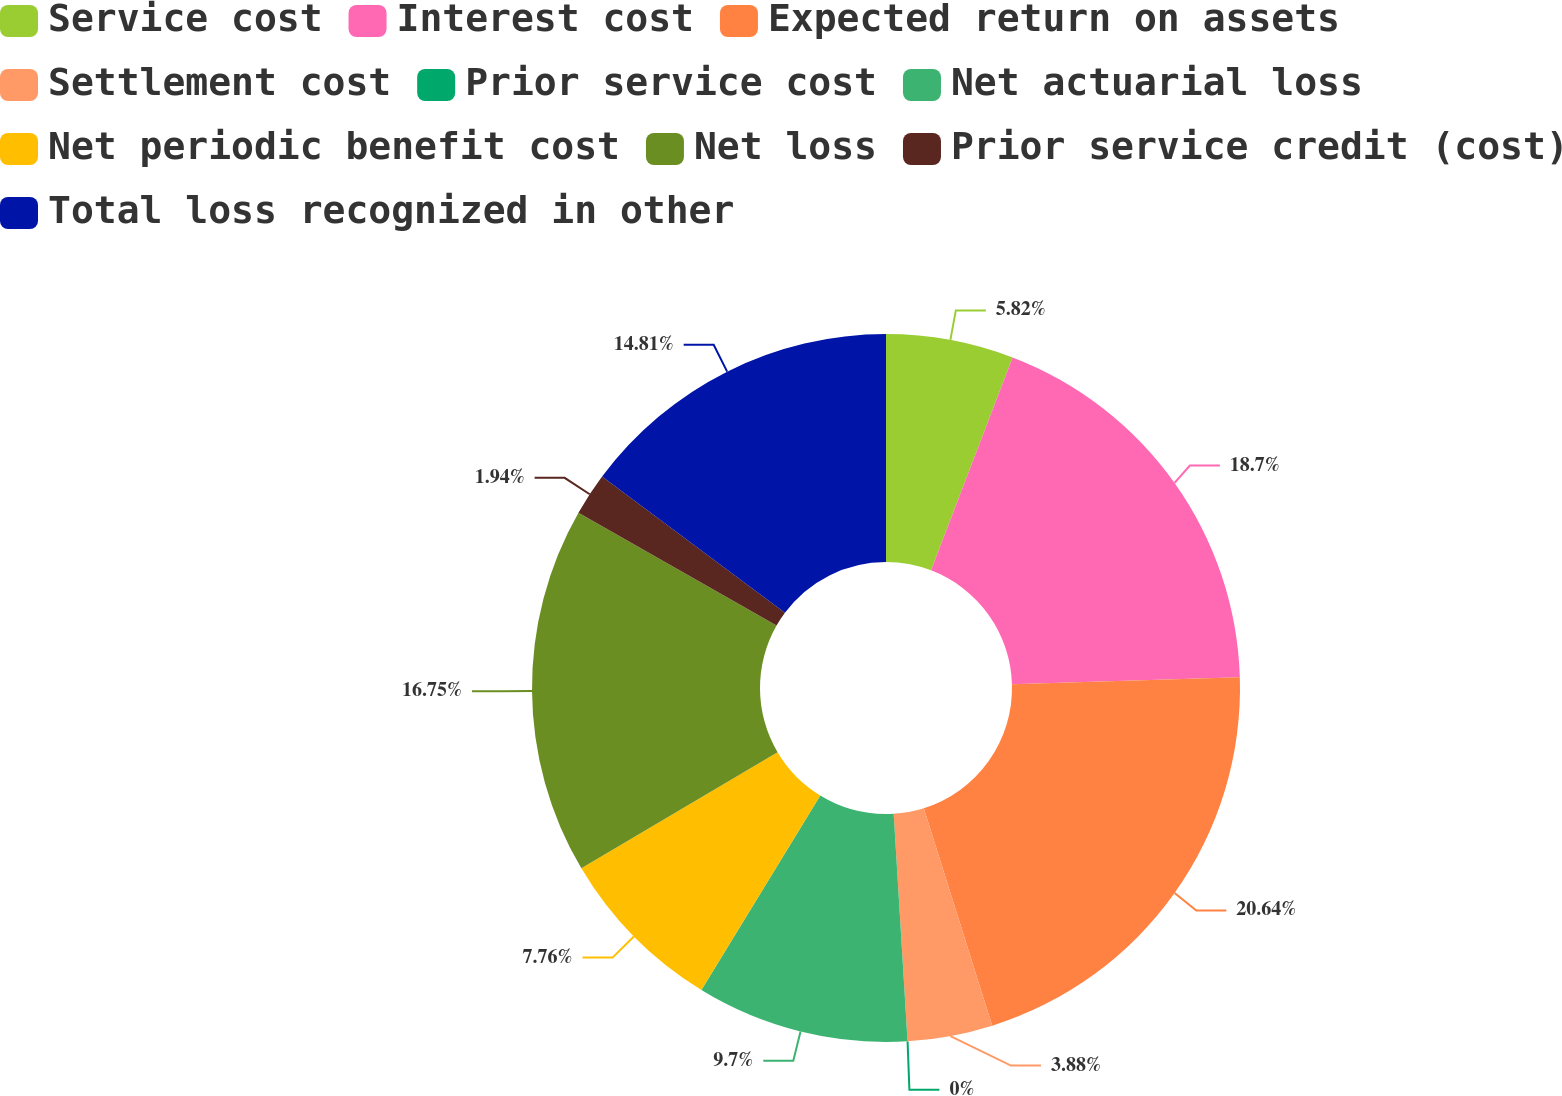<chart> <loc_0><loc_0><loc_500><loc_500><pie_chart><fcel>Service cost<fcel>Interest cost<fcel>Expected return on assets<fcel>Settlement cost<fcel>Prior service cost<fcel>Net actuarial loss<fcel>Net periodic benefit cost<fcel>Net loss<fcel>Prior service credit (cost)<fcel>Total loss recognized in other<nl><fcel>5.82%<fcel>18.69%<fcel>20.63%<fcel>3.88%<fcel>0.0%<fcel>9.7%<fcel>7.76%<fcel>16.75%<fcel>1.94%<fcel>14.81%<nl></chart> 